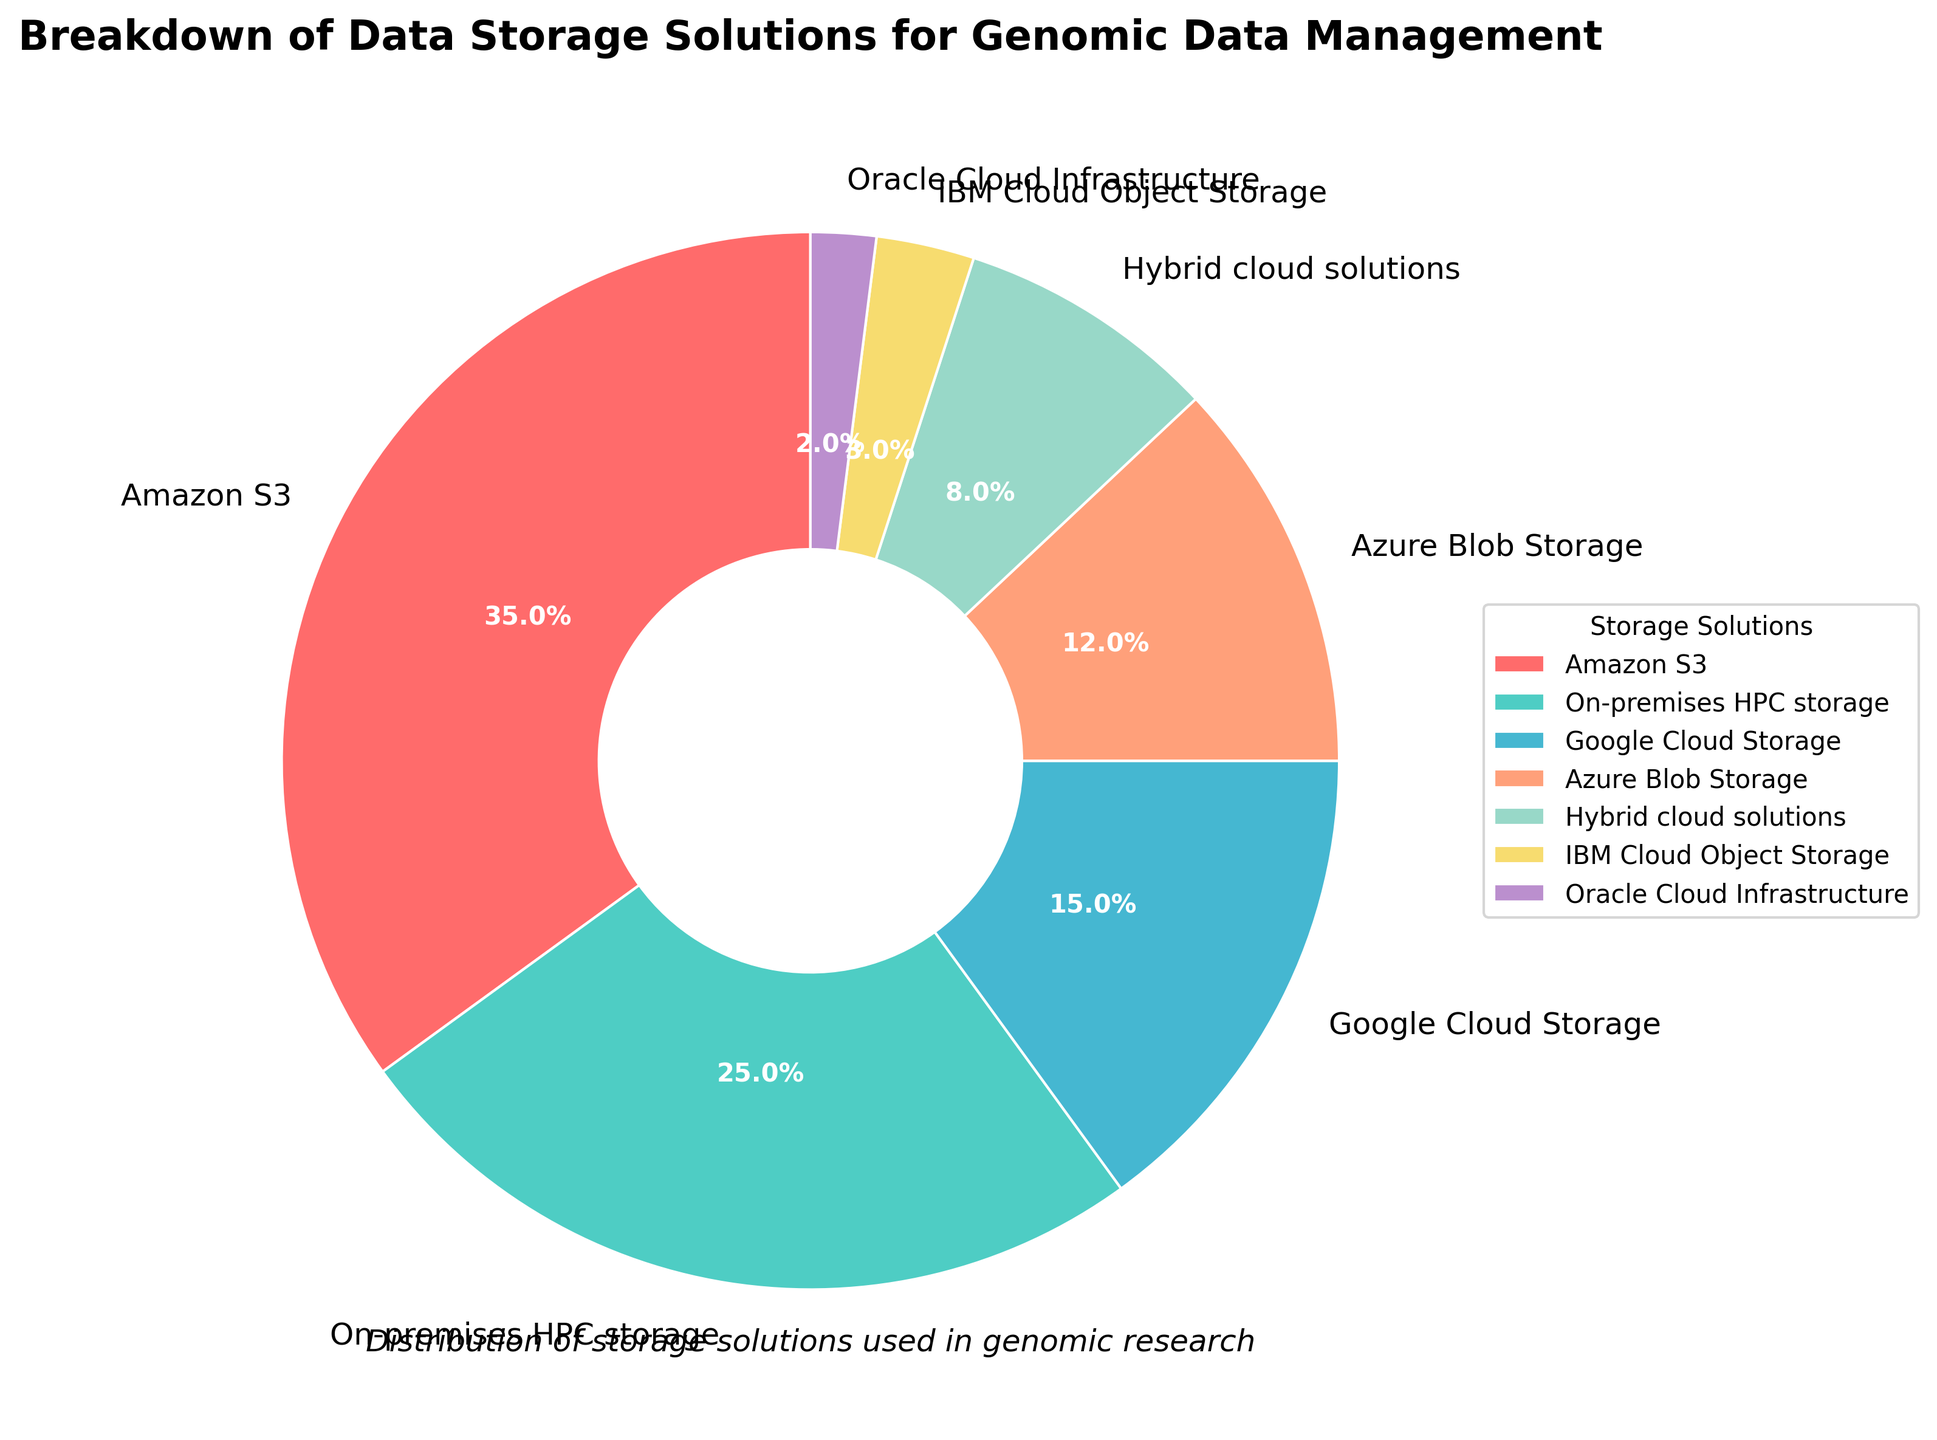What is the largest data storage solution used for genomic data management? The largest data storage solution is identified by looking for the segment of the pie chart with the largest percentage label. The label with the highest percentage is Amazon S3 with 35%.
Answer: Amazon S3 Which data storage solutions constitute less than 10% each of the total storage? We need to identify the solutions whose labeled percentage is less than 10%. The segments labeled with percentages under 10% are IBM Cloud Object Storage (3%), Oracle Cloud Infrastructure (2%), and Hybrid cloud solutions (8%).
Answer: IBM Cloud Object Storage, Oracle Cloud Infrastructure, Hybrid cloud solutions What is the combined percentage of Google Cloud Storage and Azure Blob Storage? To find the combined percentage, add the individual percentages of Google Cloud Storage (15%) and Azure Blob Storage (12%). The sum is 15% + 12% = 27%.
Answer: 27% Compare the usage of Amazon S3 and On-premises HPC storage. Which is more used and by how much? To determine which is more used, compare the percentages: Amazon S3 (35%) and On-premises HPC storage (25%). Subtract the smaller from the larger percentage: 35% - 25% = 10%. Amazon S3 is used more by 10%.
Answer: Amazon S3, 10% What is the total percentage of storage solutions provided by cloud services? To find the total percentage of cloud storage solutions, sum the percentages of Amazon S3 (35%), Google Cloud Storage (15%), Azure Blob Storage (12%), IBM Cloud Object Storage (3%), and Oracle Cloud Infrastructure (2%). The total is 35% + 15% + 12% + 3% + 2% = 67%.
Answer: 67% Which segment is represented by the green color? By identifying the color associated with each segment in the pie chart, the segment represented by the green color corresponds to On-premises HPC storage, which is labeled with 25%.
Answer: On-premises HPC storage How much more is the percentage of Amazon S3 compared to the combined total of IBM Cloud Object Storage and Oracle Cloud Infrastructure? First, sum the percentages of IBM Cloud Object Storage (3%) and Oracle Cloud Infrastructure (2%) to get 3% + 2% = 5%. Then, subtract this sum from Amazon S3's percentage: 35% - 5% = 30%. Amazon S3 is used 30% more.
Answer: 30% If the total storage solutions were to be equally distributed among the seven listed solutions, what would be each solution's percentage? How much percentage deviation does Amazon S3 have from this equal distribution? Equal distribution would mean dividing 100% by 7, which equals approximately 14.29%. Amazon S3's percentage is 35%. The deviation is calculated as 35% - 14.29% ≈ 20.71%.
Answer: 14.29%, 20.71% 